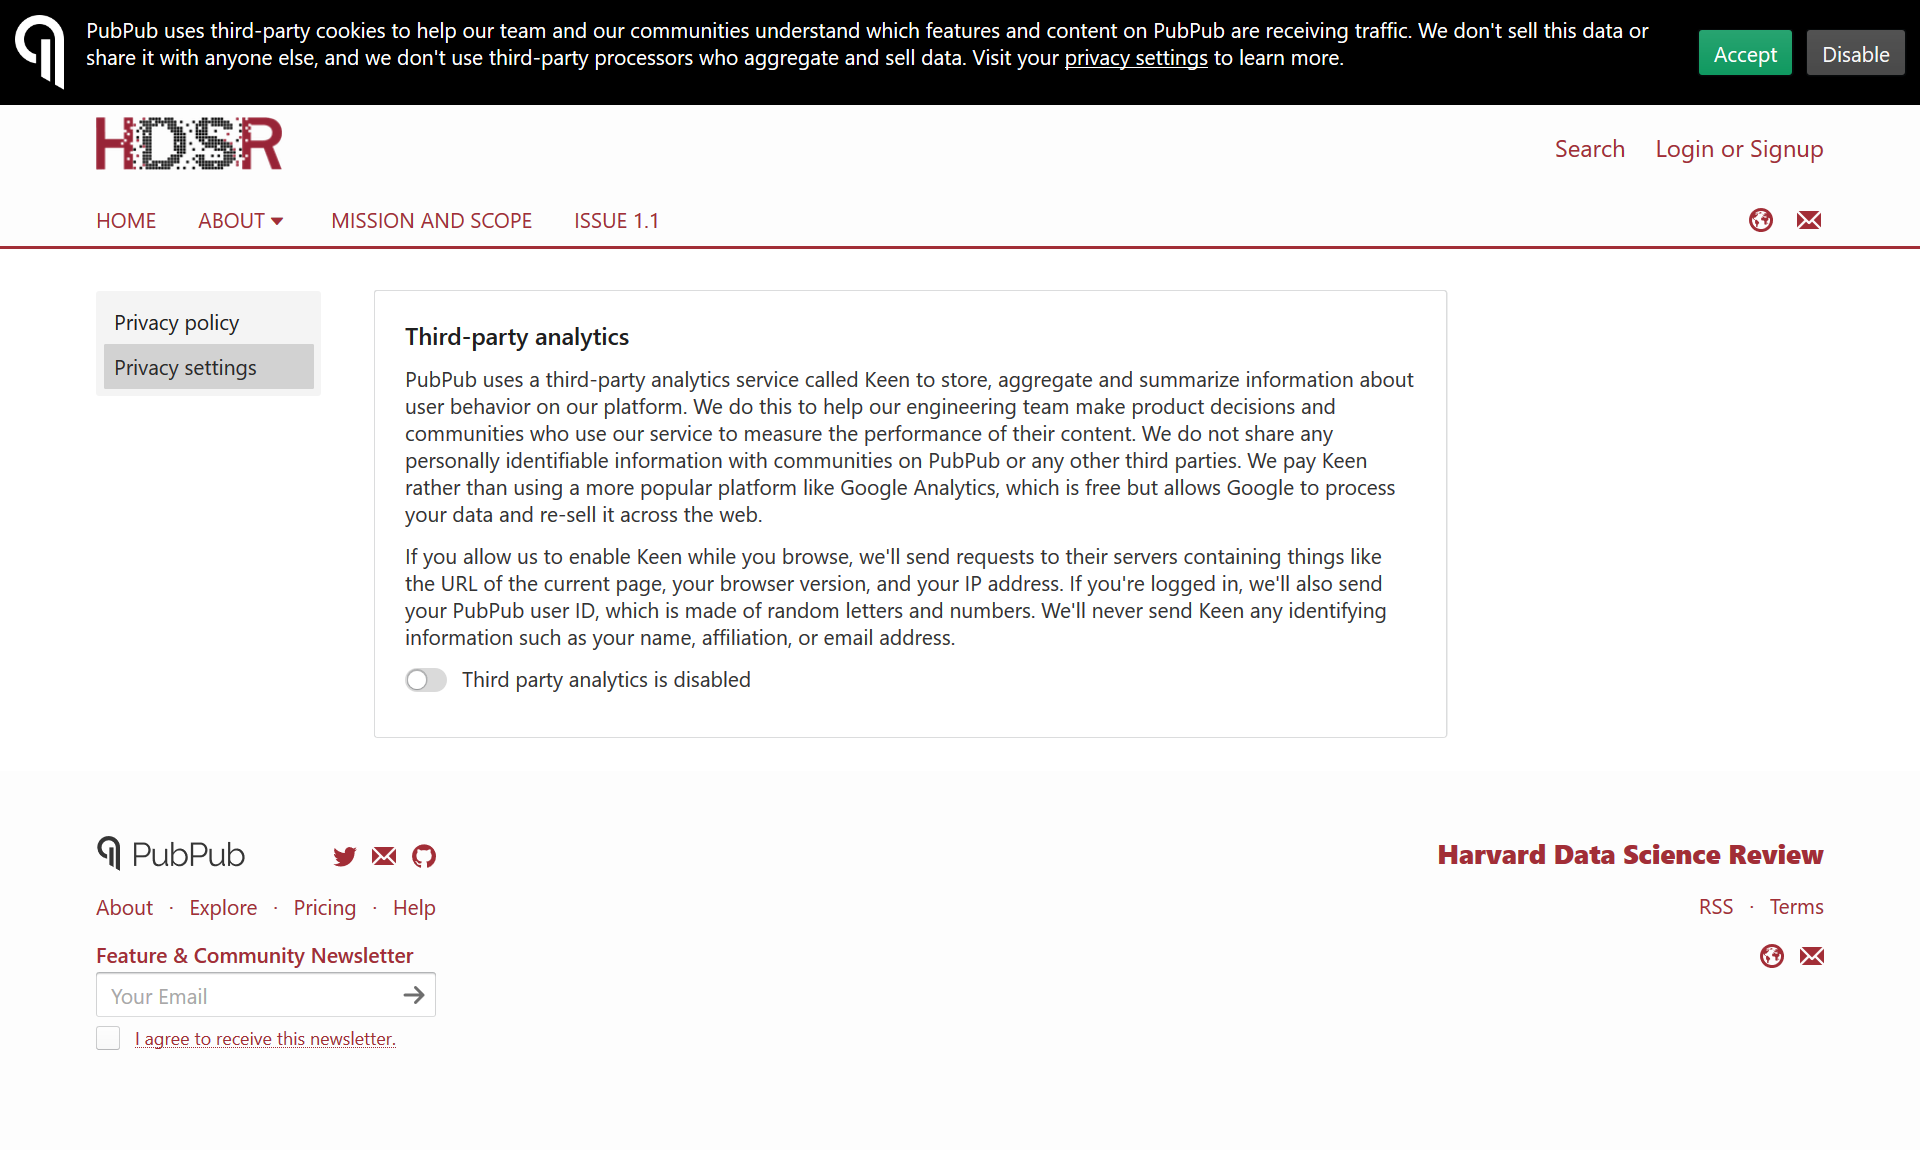Mention a couple of crucial points in this snapshot. Google Analytics is more popular than Keen. PubPub will never provide any identifying information to Keen. Keen, a third-party analytics, is a feature that users have the option to enable. 